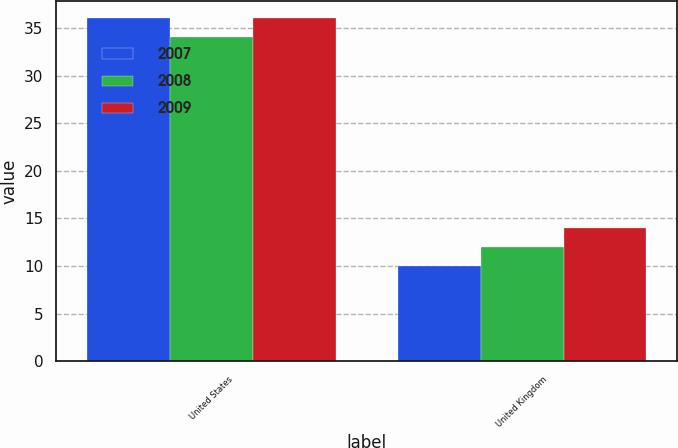Convert chart to OTSL. <chart><loc_0><loc_0><loc_500><loc_500><stacked_bar_chart><ecel><fcel>United States<fcel>United Kingdom<nl><fcel>2007<fcel>36<fcel>10<nl><fcel>2008<fcel>34<fcel>12<nl><fcel>2009<fcel>36<fcel>14<nl></chart> 